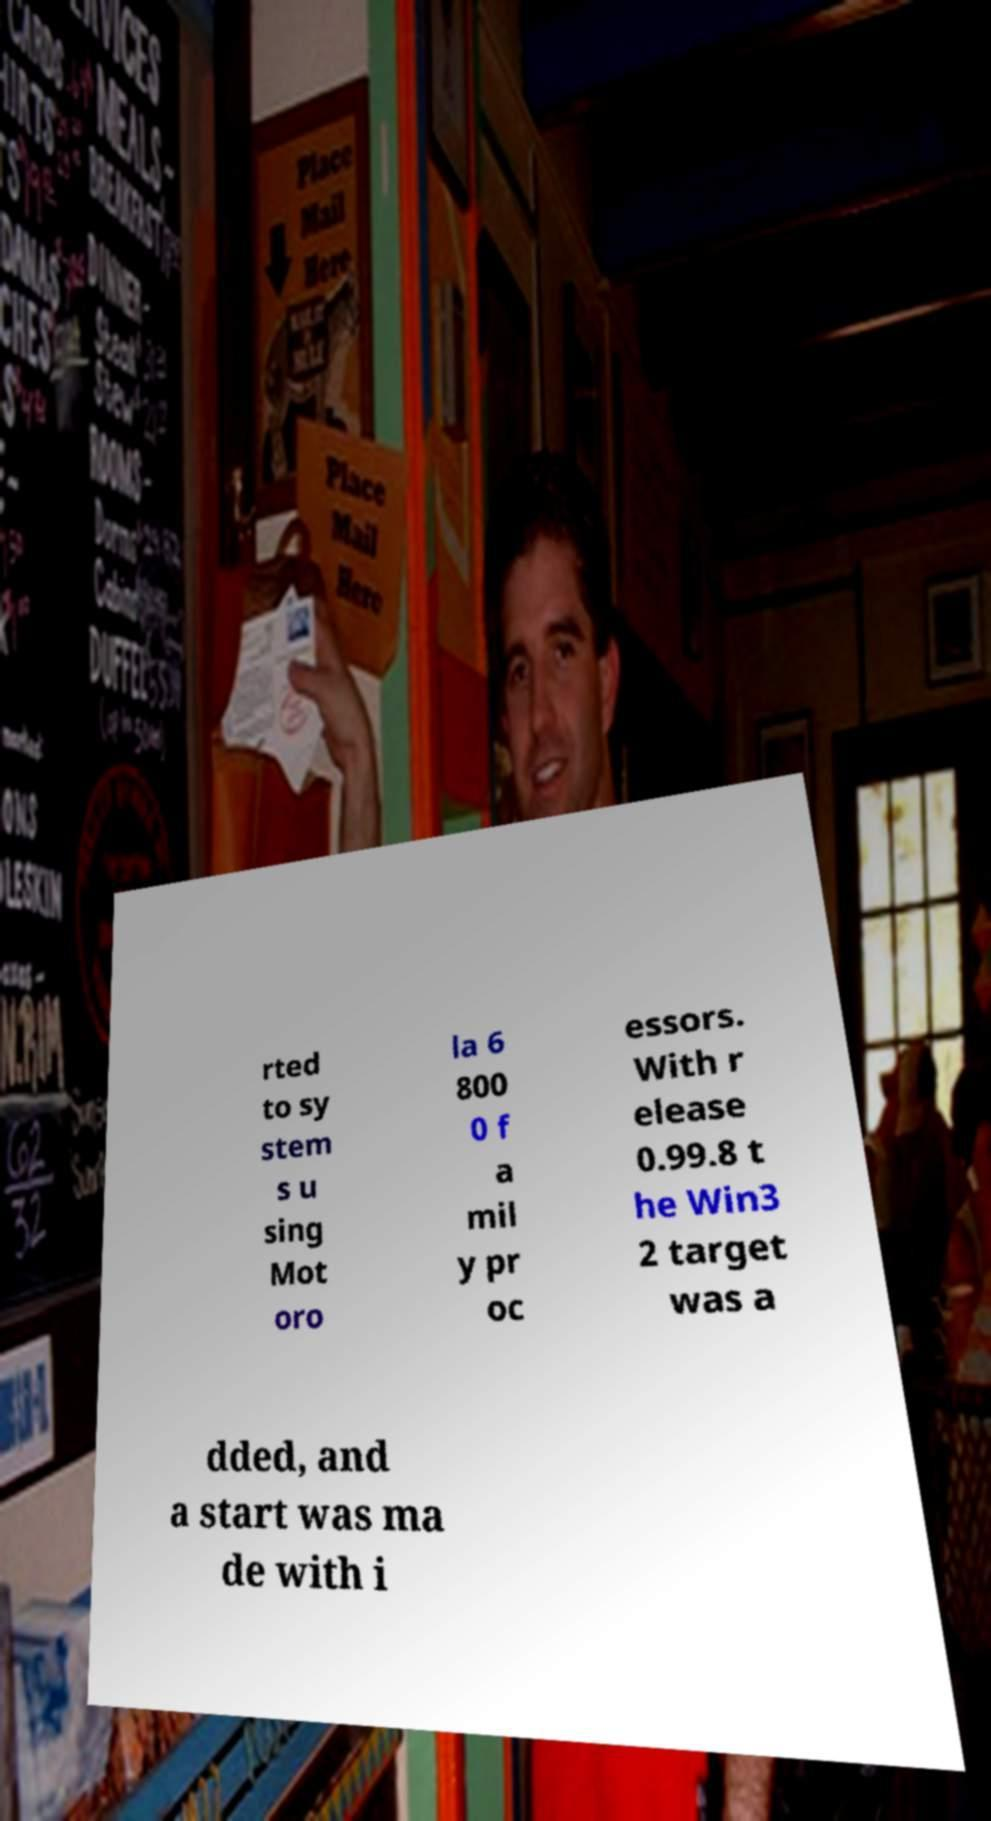I need the written content from this picture converted into text. Can you do that? rted to sy stem s u sing Mot oro la 6 800 0 f a mil y pr oc essors. With r elease 0.99.8 t he Win3 2 target was a dded, and a start was ma de with i 